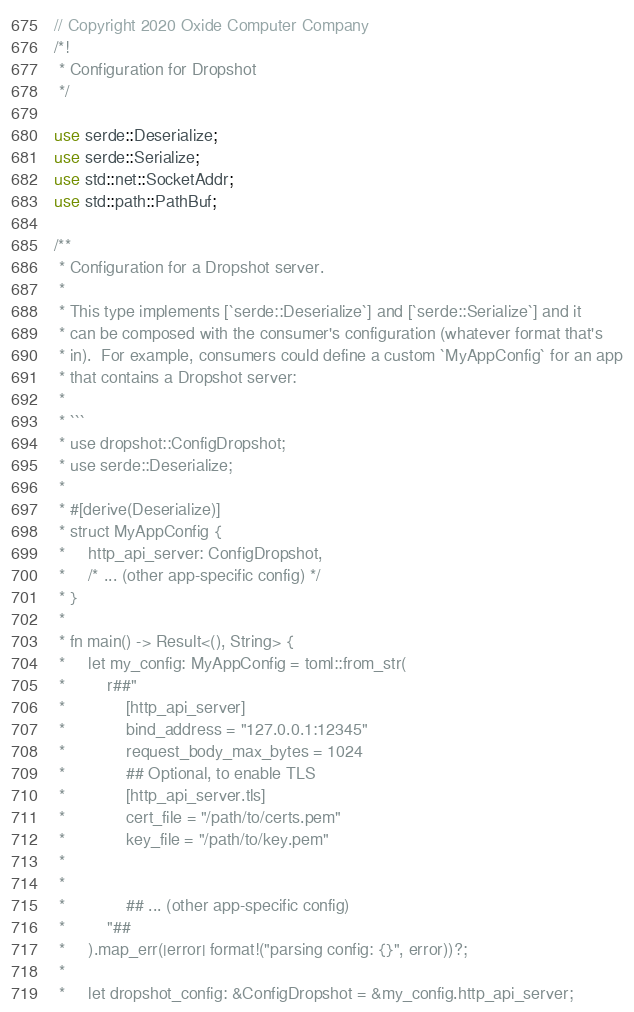<code> <loc_0><loc_0><loc_500><loc_500><_Rust_>// Copyright 2020 Oxide Computer Company
/*!
 * Configuration for Dropshot
 */

use serde::Deserialize;
use serde::Serialize;
use std::net::SocketAddr;
use std::path::PathBuf;

/**
 * Configuration for a Dropshot server.
 *
 * This type implements [`serde::Deserialize`] and [`serde::Serialize`] and it
 * can be composed with the consumer's configuration (whatever format that's
 * in).  For example, consumers could define a custom `MyAppConfig` for an app
 * that contains a Dropshot server:
 *
 * ```
 * use dropshot::ConfigDropshot;
 * use serde::Deserialize;
 *
 * #[derive(Deserialize)]
 * struct MyAppConfig {
 *     http_api_server: ConfigDropshot,
 *     /* ... (other app-specific config) */
 * }
 *
 * fn main() -> Result<(), String> {
 *     let my_config: MyAppConfig = toml::from_str(
 *         r##"
 *             [http_api_server]
 *             bind_address = "127.0.0.1:12345"
 *             request_body_max_bytes = 1024
 *             ## Optional, to enable TLS
 *             [http_api_server.tls]
 *             cert_file = "/path/to/certs.pem"
 *             key_file = "/path/to/key.pem"
 *
 *
 *             ## ... (other app-specific config)
 *         "##
 *     ).map_err(|error| format!("parsing config: {}", error))?;
 *
 *     let dropshot_config: &ConfigDropshot = &my_config.http_api_server;</code> 